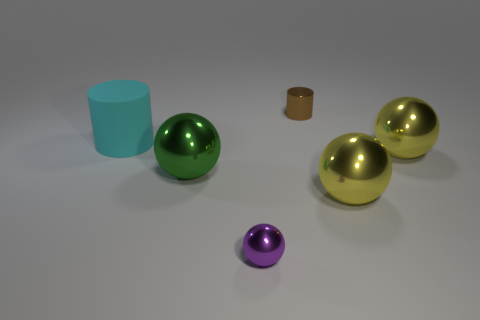Are there more tiny cylinders behind the tiny brown object than red rubber things? Upon examining the image, it's clear that there are no tiny cylinders behind the tiny brown object. In fact, there are no red rubber things present at all. The items consist of spheres and a cylinder, and the mentioned tiny brown object is a small cylinder with no other cylinders behind it. 